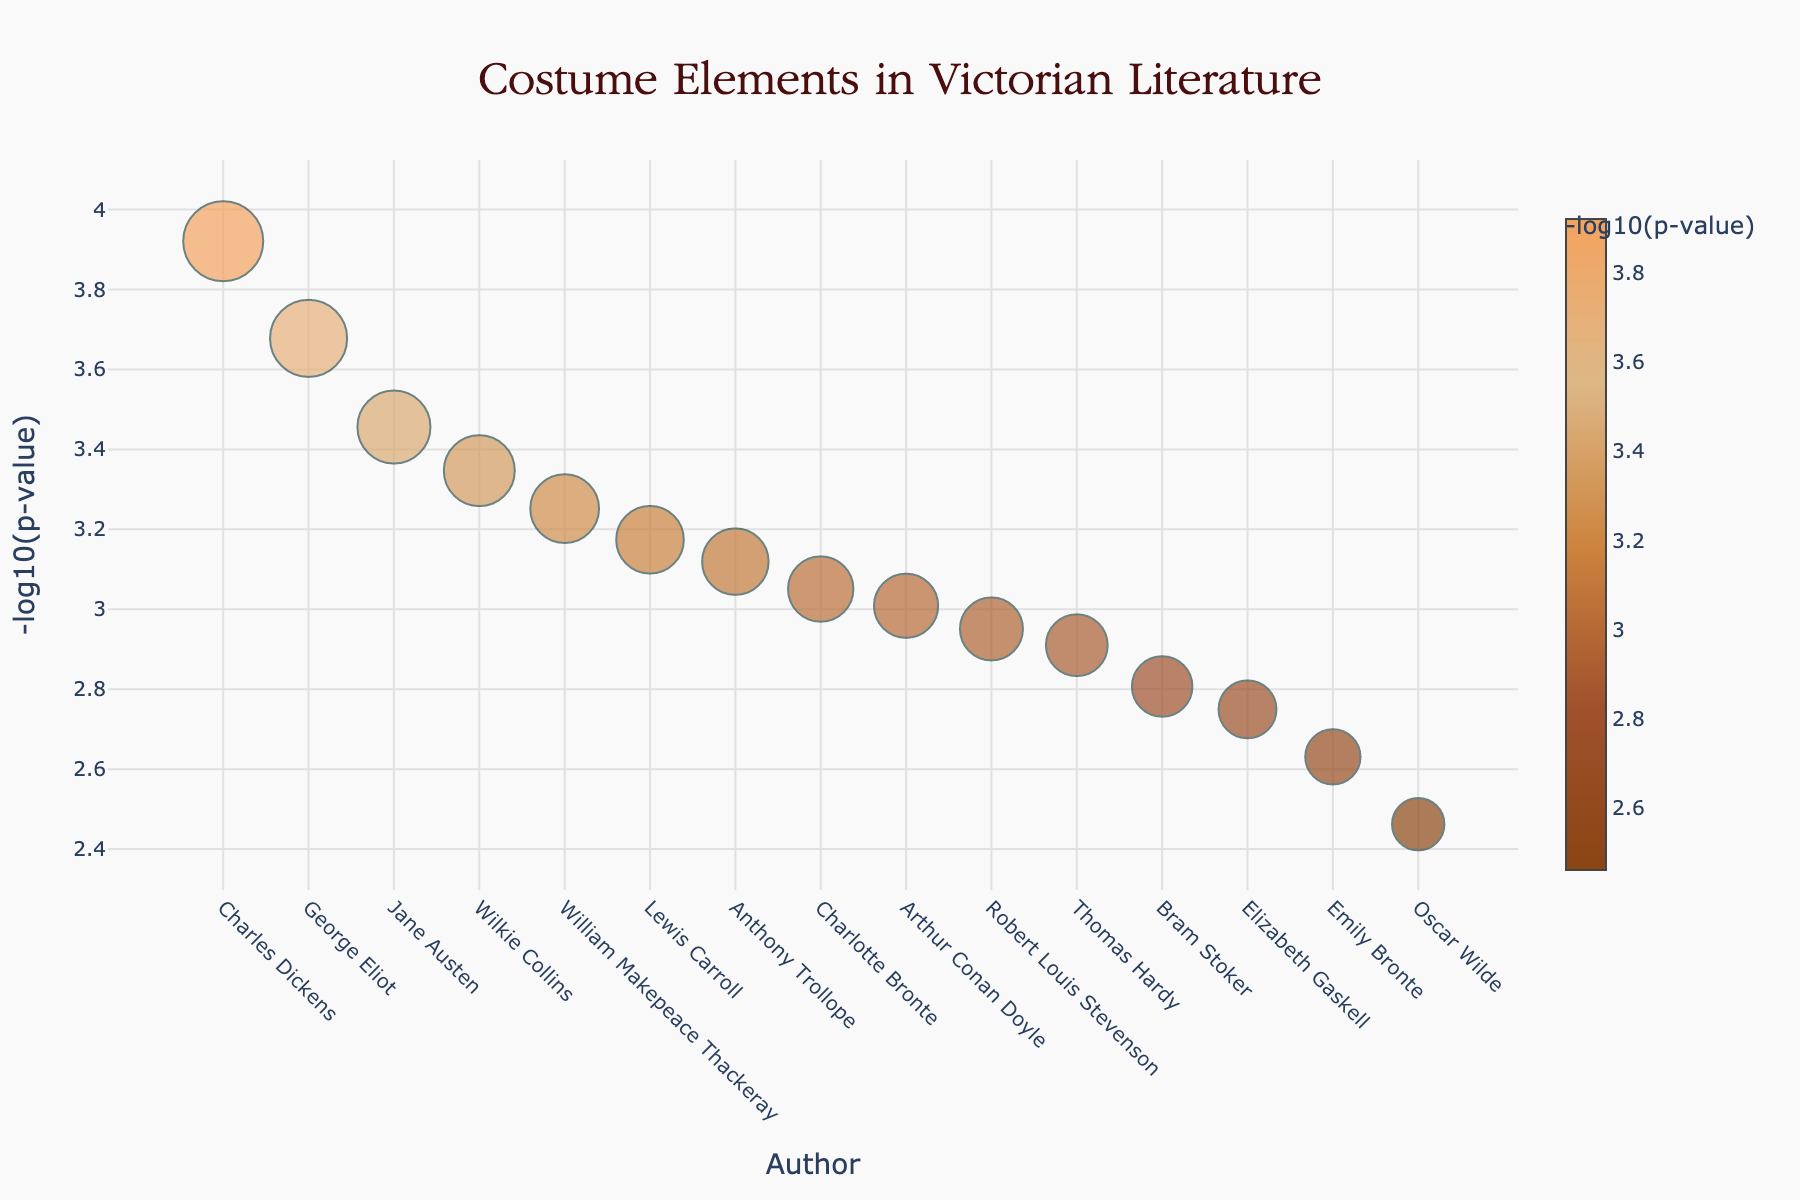How many authors are depicted in the plot? Count the number of distinct authors along the x-axis. There are 15 distinct authors present in the plot.
Answer: 15 Which author is associated with the lowest p-value costume element and what is that element? Identify the author with the highest -log10(p-value), which represents the lowest p-value. The author is Charles Dickens and the costume element is a Top Hat.
Answer: Charles Dickens, Top Hat What is the y-axis value representing for each data point? The y-axis represents -log10 of the p-value for each costume element occurrence. This transformation is common in Manhattan plots to emphasize smaller p-values.
Answer: -log10(p-value) Which costume element has the highest occurrence count and which author is it attributed to? Locate the largest point (marker) on the plot to identify the highest occurrence count. The largest marker is attributed to Charles Dickens with the Top Hat element.
Answer: Top Hat, Charles Dickens How many costume elements appear with an occurrence count of 25 or more? Count all the markers with sizes representing occurrence counts of 25 or larger. There are 11 such costume elements.
Answer: 11 Which costume element has the largest size marker for female authors, and who is the author? Review the markers associated with female authors and determine the largest one. The largest marker is associated with Jane Austen and the costume element is Gloves.
Answer: Gloves, Jane Austen What is the difference in the -log10(p-value) between the costume element with the highest occurrence and the one with the lowest occurrence? The highest occurrence is 42, and the lowest is 18. Calculate their -log10(p-value) values and find their difference. For occurrence 42 (-log10(p-value) = 3.92) and 18 (-log10(p-value) = 2.46), the difference is 3.92 - 2.46.
Answer: 1.46 Which two costume elements have -log10(p-values) closest to 3.5? Identify the two points whose y-values are closest to 3.5 on the y-axis. These are George Eliot's Bonnet and Wilkie Collins' Pocket Watch.
Answer: Bonnet, Pocket Watch How does the y-axis value change as the p-value of a costume element decreases? The y-axis value, -log10(p-value), increases as the p-value decreases. This inverse relationship is typical in Manhattan plots used to highlight low p-values.
Answer: Increases Who has the highest number of different costume elements with a p-value less than 0.001? Count the number of unique costume elements for each author with a p-value < 0.001. Charles Dickens has the highest number with one element (Top Hat). Jane Austen also has one element (Gloves), but multiple authors can share the highest count.
Answer: Charles Dickens, Jane Austen 